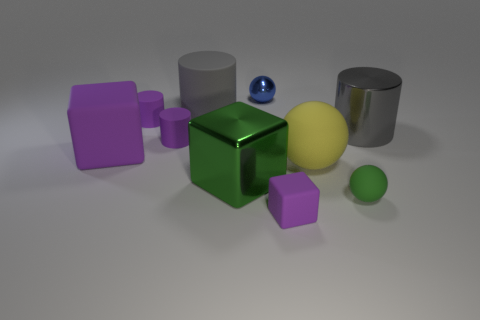Subtract all matte cubes. How many cubes are left? 1 Subtract all blue blocks. How many gray cylinders are left? 2 Subtract 1 spheres. How many spheres are left? 2 Subtract all yellow blocks. Subtract all green balls. How many blocks are left? 3 Subtract 0 blue cubes. How many objects are left? 10 Subtract all cubes. How many objects are left? 7 Subtract all cyan blocks. Subtract all small green matte objects. How many objects are left? 9 Add 6 large metal things. How many large metal things are left? 8 Add 8 small green metal balls. How many small green metal balls exist? 8 